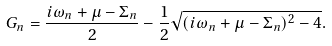Convert formula to latex. <formula><loc_0><loc_0><loc_500><loc_500>G _ { n } = \frac { i \omega _ { n } + \mu - \Sigma _ { n } } { 2 } - \frac { 1 } { 2 } \sqrt { ( i \omega _ { n } + \mu - \Sigma _ { n } ) ^ { 2 } - 4 } .</formula> 